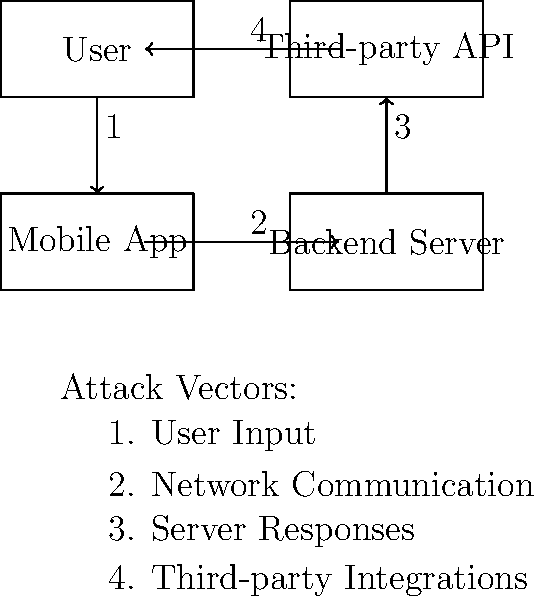In the mobile app ecosystem diagram, which component is most vulnerable to SQL injection attacks? To identify the component most vulnerable to SQL injection attacks, let's analyze each component in the diagram:

1. User: Users interact with the mobile app but don't directly handle SQL queries.

2. Mobile App: While the app processes user input, it typically doesn't execute SQL queries directly.

3. Third-party API: These are external services and usually don't have direct access to the app's database.

4. Backend Server: This is where the database is typically located and SQL queries are executed.

SQL injection attacks occur when malicious SQL statements are inserted into application queries. These attacks primarily target the component that interacts directly with the database, which is usually the backend server.

The backend server receives requests from the mobile app, processes them, and often needs to query the database to fulfill these requests. If input validation and sanitization are not properly implemented on the server-side, it becomes vulnerable to SQL injection attacks.

Therefore, among the given components, the backend server is most susceptible to SQL injection attacks.
Answer: Backend Server 